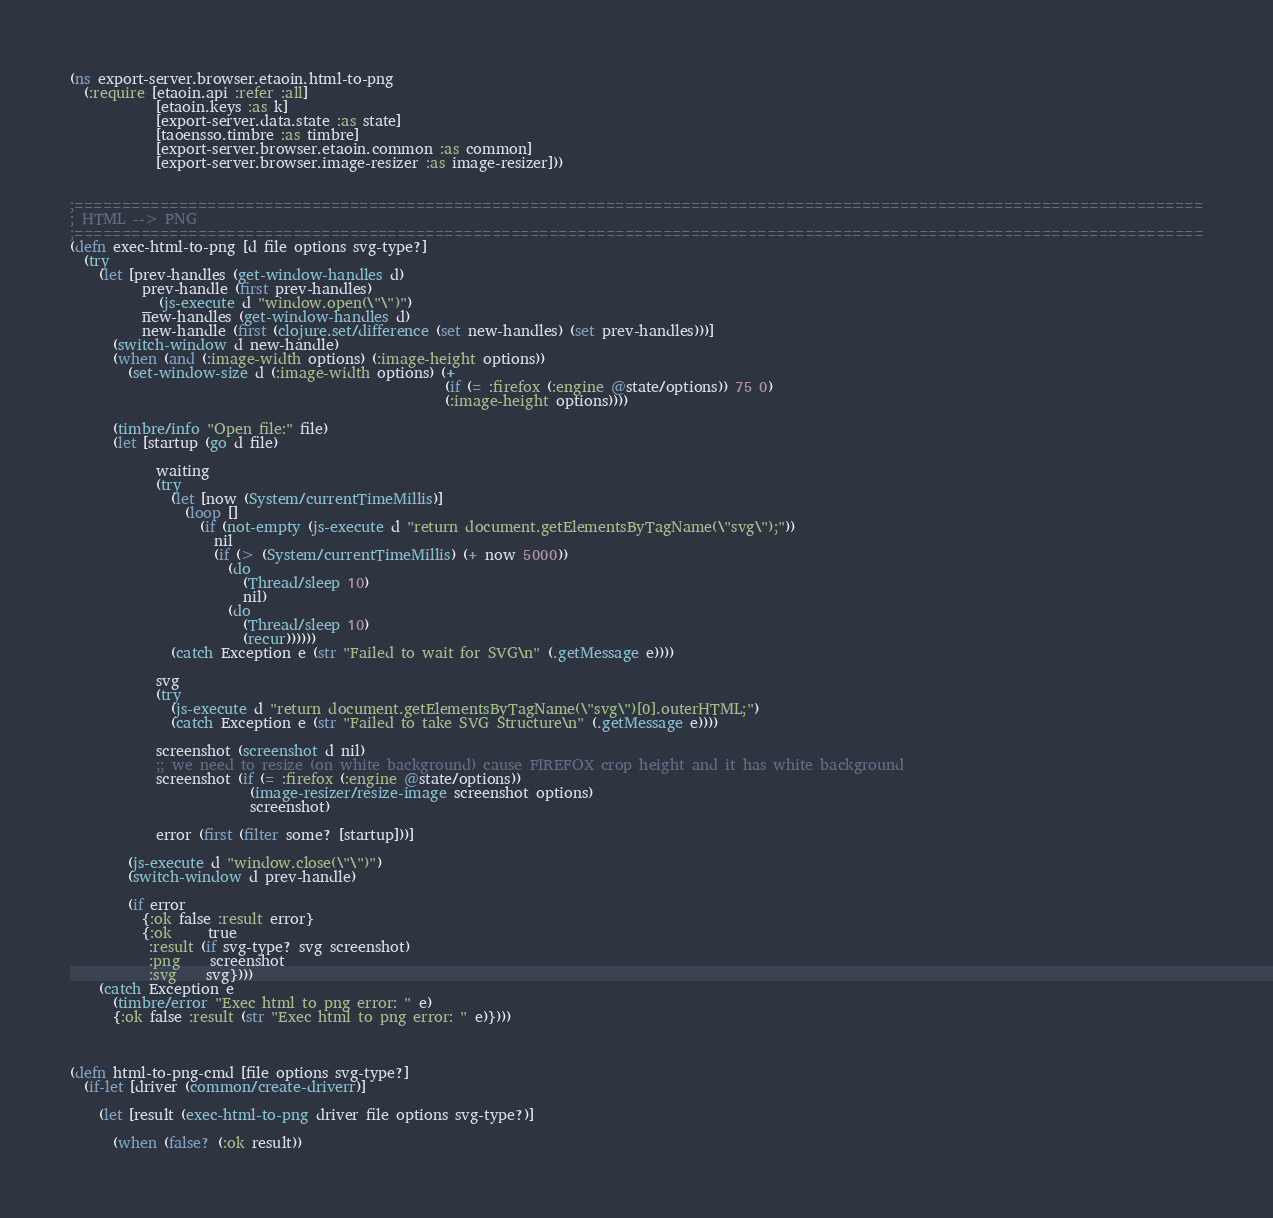Convert code to text. <code><loc_0><loc_0><loc_500><loc_500><_Clojure_>(ns export-server.browser.etaoin.html-to-png
  (:require [etaoin.api :refer :all]
            [etaoin.keys :as k]
            [export-server.data.state :as state]
            [taoensso.timbre :as timbre]
            [export-server.browser.etaoin.common :as common]
            [export-server.browser.image-resizer :as image-resizer]))


;=======================================================================================================================
; HTML --> PNG
;=======================================================================================================================
(defn exec-html-to-png [d file options svg-type?]
  (try
    (let [prev-handles (get-window-handles d)
          prev-handle (first prev-handles)
          _ (js-execute d "window.open(\"\")")
          new-handles (get-window-handles d)
          new-handle (first (clojure.set/difference (set new-handles) (set prev-handles)))]
      (switch-window d new-handle)
      (when (and (:image-width options) (:image-height options))
        (set-window-size d (:image-width options) (+
                                                    (if (= :firefox (:engine @state/options)) 75 0)
                                                    (:image-height options))))

      (timbre/info "Open file:" file)
      (let [startup (go d file)

            waiting
            (try
              (let [now (System/currentTimeMillis)]
                (loop []
                  (if (not-empty (js-execute d "return document.getElementsByTagName(\"svg\");"))
                    nil
                    (if (> (System/currentTimeMillis) (+ now 5000))
                      (do
                        (Thread/sleep 10)
                        nil)
                      (do
                        (Thread/sleep 10)
                        (recur))))))
              (catch Exception e (str "Failed to wait for SVG\n" (.getMessage e))))

            svg
            (try
              (js-execute d "return document.getElementsByTagName(\"svg\")[0].outerHTML;")
              (catch Exception e (str "Failed to take SVG Structure\n" (.getMessage e))))

            screenshot (screenshot d nil)
            ;; we need to resize (on white background) cause FIREFOX crop height and it has white background
            screenshot (if (= :firefox (:engine @state/options))
                         (image-resizer/resize-image screenshot options)
                         screenshot)

            error (first (filter some? [startup]))]

        (js-execute d "window.close(\"\")")
        (switch-window d prev-handle)

        (if error
          {:ok false :result error}
          {:ok     true
           :result (if svg-type? svg screenshot)
           :png    screenshot
           :svg    svg})))
    (catch Exception e
      (timbre/error "Exec html to png error: " e)
      {:ok false :result (str "Exec html to png error: " e)})))



(defn html-to-png-cmd [file options svg-type?]
  (if-let [driver (common/create-driverr)]

    (let [result (exec-html-to-png driver file options svg-type?)]

      (when (false? (:ok result))</code> 